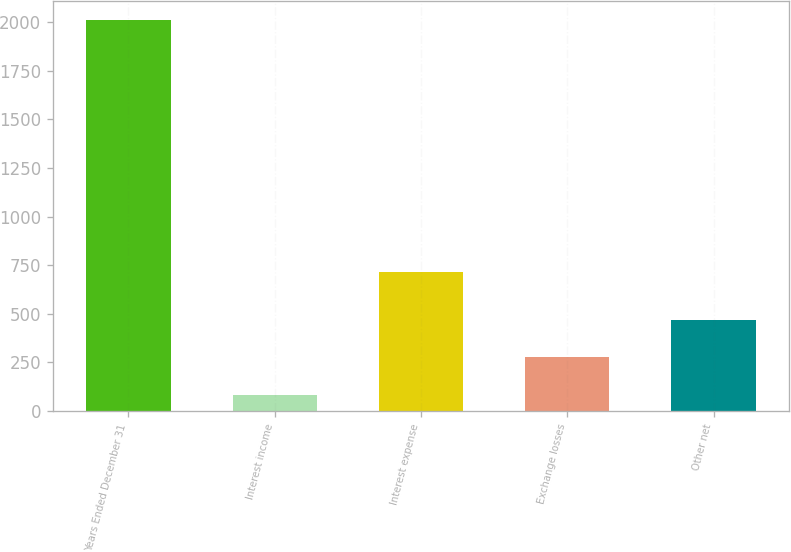<chart> <loc_0><loc_0><loc_500><loc_500><bar_chart><fcel>Years Ended December 31<fcel>Interest income<fcel>Interest expense<fcel>Exchange losses<fcel>Other net<nl><fcel>2010<fcel>83<fcel>715<fcel>275.7<fcel>468.4<nl></chart> 